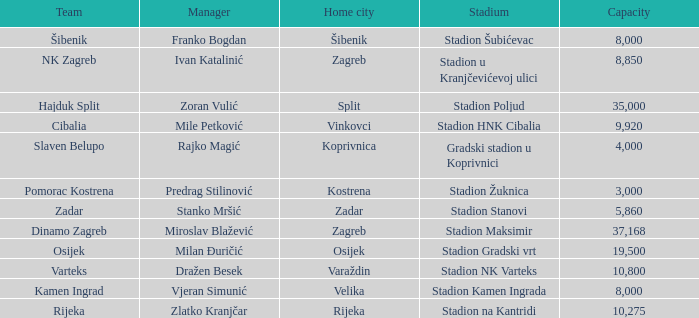What team has a home city of Koprivnica? Slaven Belupo. Could you parse the entire table as a dict? {'header': ['Team', 'Manager', 'Home city', 'Stadium', 'Capacity'], 'rows': [['Šibenik', 'Franko Bogdan', 'Šibenik', 'Stadion Šubićevac', '8,000'], ['NK Zagreb', 'Ivan Katalinić', 'Zagreb', 'Stadion u Kranjčevićevoj ulici', '8,850'], ['Hajduk Split', 'Zoran Vulić', 'Split', 'Stadion Poljud', '35,000'], ['Cibalia', 'Mile Petković', 'Vinkovci', 'Stadion HNK Cibalia', '9,920'], ['Slaven Belupo', 'Rajko Magić', 'Koprivnica', 'Gradski stadion u Koprivnici', '4,000'], ['Pomorac Kostrena', 'Predrag Stilinović', 'Kostrena', 'Stadion Žuknica', '3,000'], ['Zadar', 'Stanko Mršić', 'Zadar', 'Stadion Stanovi', '5,860'], ['Dinamo Zagreb', 'Miroslav Blažević', 'Zagreb', 'Stadion Maksimir', '37,168'], ['Osijek', 'Milan Đuričić', 'Osijek', 'Stadion Gradski vrt', '19,500'], ['Varteks', 'Dražen Besek', 'Varaždin', 'Stadion NK Varteks', '10,800'], ['Kamen Ingrad', 'Vjeran Simunić', 'Velika', 'Stadion Kamen Ingrada', '8,000'], ['Rijeka', 'Zlatko Kranjčar', 'Rijeka', 'Stadion na Kantridi', '10,275']]} 